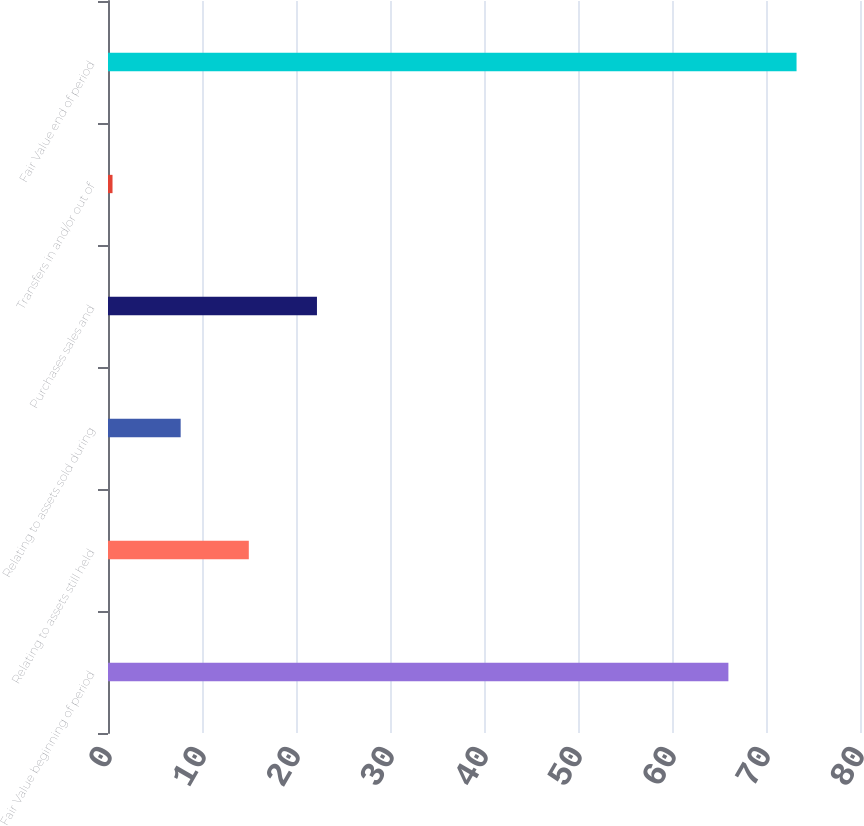Convert chart to OTSL. <chart><loc_0><loc_0><loc_500><loc_500><bar_chart><fcel>Fair Value beginning of period<fcel>Relating to assets still held<fcel>Relating to assets sold during<fcel>Purchases sales and<fcel>Transfers in and/or out of<fcel>Fair Value end of period<nl><fcel>66<fcel>14.98<fcel>7.73<fcel>22.23<fcel>0.48<fcel>73.25<nl></chart> 